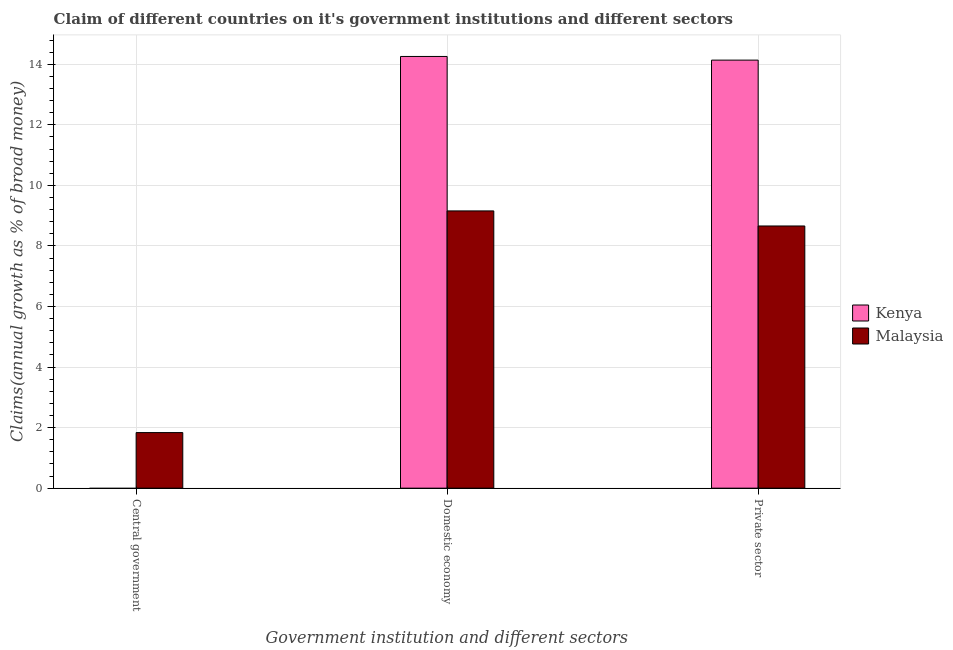Are the number of bars per tick equal to the number of legend labels?
Your response must be concise. No. How many bars are there on the 1st tick from the left?
Offer a very short reply. 1. What is the label of the 1st group of bars from the left?
Offer a terse response. Central government. What is the percentage of claim on the domestic economy in Kenya?
Make the answer very short. 14.26. Across all countries, what is the maximum percentage of claim on the domestic economy?
Ensure brevity in your answer.  14.26. In which country was the percentage of claim on the domestic economy maximum?
Your answer should be compact. Kenya. What is the total percentage of claim on the central government in the graph?
Your answer should be compact. 1.84. What is the difference between the percentage of claim on the private sector in Kenya and that in Malaysia?
Your answer should be very brief. 5.48. What is the difference between the percentage of claim on the central government in Kenya and the percentage of claim on the private sector in Malaysia?
Give a very brief answer. -8.66. What is the average percentage of claim on the central government per country?
Give a very brief answer. 0.92. What is the difference between the percentage of claim on the central government and percentage of claim on the private sector in Malaysia?
Offer a very short reply. -6.82. In how many countries, is the percentage of claim on the central government greater than 9.6 %?
Give a very brief answer. 0. What is the ratio of the percentage of claim on the domestic economy in Kenya to that in Malaysia?
Provide a short and direct response. 1.56. Is the percentage of claim on the domestic economy in Kenya less than that in Malaysia?
Make the answer very short. No. Is the difference between the percentage of claim on the private sector in Kenya and Malaysia greater than the difference between the percentage of claim on the domestic economy in Kenya and Malaysia?
Offer a terse response. Yes. What is the difference between the highest and the second highest percentage of claim on the private sector?
Provide a succinct answer. 5.48. What is the difference between the highest and the lowest percentage of claim on the central government?
Keep it short and to the point. 1.84. In how many countries, is the percentage of claim on the domestic economy greater than the average percentage of claim on the domestic economy taken over all countries?
Your answer should be compact. 1. How many countries are there in the graph?
Your answer should be very brief. 2. What is the difference between two consecutive major ticks on the Y-axis?
Provide a succinct answer. 2. Are the values on the major ticks of Y-axis written in scientific E-notation?
Provide a short and direct response. No. Does the graph contain any zero values?
Make the answer very short. Yes. How are the legend labels stacked?
Offer a terse response. Vertical. What is the title of the graph?
Make the answer very short. Claim of different countries on it's government institutions and different sectors. Does "Angola" appear as one of the legend labels in the graph?
Offer a very short reply. No. What is the label or title of the X-axis?
Give a very brief answer. Government institution and different sectors. What is the label or title of the Y-axis?
Offer a terse response. Claims(annual growth as % of broad money). What is the Claims(annual growth as % of broad money) in Malaysia in Central government?
Give a very brief answer. 1.84. What is the Claims(annual growth as % of broad money) in Kenya in Domestic economy?
Your answer should be very brief. 14.26. What is the Claims(annual growth as % of broad money) of Malaysia in Domestic economy?
Provide a succinct answer. 9.16. What is the Claims(annual growth as % of broad money) in Kenya in Private sector?
Provide a short and direct response. 14.14. What is the Claims(annual growth as % of broad money) in Malaysia in Private sector?
Your answer should be compact. 8.66. Across all Government institution and different sectors, what is the maximum Claims(annual growth as % of broad money) in Kenya?
Ensure brevity in your answer.  14.26. Across all Government institution and different sectors, what is the maximum Claims(annual growth as % of broad money) in Malaysia?
Provide a succinct answer. 9.16. Across all Government institution and different sectors, what is the minimum Claims(annual growth as % of broad money) in Kenya?
Offer a very short reply. 0. Across all Government institution and different sectors, what is the minimum Claims(annual growth as % of broad money) in Malaysia?
Your answer should be compact. 1.84. What is the total Claims(annual growth as % of broad money) of Kenya in the graph?
Provide a succinct answer. 28.39. What is the total Claims(annual growth as % of broad money) of Malaysia in the graph?
Provide a short and direct response. 19.65. What is the difference between the Claims(annual growth as % of broad money) in Malaysia in Central government and that in Domestic economy?
Ensure brevity in your answer.  -7.32. What is the difference between the Claims(annual growth as % of broad money) of Malaysia in Central government and that in Private sector?
Your answer should be compact. -6.82. What is the difference between the Claims(annual growth as % of broad money) in Kenya in Domestic economy and that in Private sector?
Offer a terse response. 0.12. What is the difference between the Claims(annual growth as % of broad money) in Malaysia in Domestic economy and that in Private sector?
Give a very brief answer. 0.5. What is the difference between the Claims(annual growth as % of broad money) of Kenya in Domestic economy and the Claims(annual growth as % of broad money) of Malaysia in Private sector?
Your response must be concise. 5.6. What is the average Claims(annual growth as % of broad money) of Kenya per Government institution and different sectors?
Provide a succinct answer. 9.46. What is the average Claims(annual growth as % of broad money) in Malaysia per Government institution and different sectors?
Your answer should be compact. 6.55. What is the difference between the Claims(annual growth as % of broad money) of Kenya and Claims(annual growth as % of broad money) of Malaysia in Domestic economy?
Offer a very short reply. 5.1. What is the difference between the Claims(annual growth as % of broad money) in Kenya and Claims(annual growth as % of broad money) in Malaysia in Private sector?
Ensure brevity in your answer.  5.48. What is the ratio of the Claims(annual growth as % of broad money) of Malaysia in Central government to that in Domestic economy?
Keep it short and to the point. 0.2. What is the ratio of the Claims(annual growth as % of broad money) of Malaysia in Central government to that in Private sector?
Your answer should be compact. 0.21. What is the ratio of the Claims(annual growth as % of broad money) in Kenya in Domestic economy to that in Private sector?
Offer a very short reply. 1.01. What is the ratio of the Claims(annual growth as % of broad money) of Malaysia in Domestic economy to that in Private sector?
Provide a succinct answer. 1.06. What is the difference between the highest and the second highest Claims(annual growth as % of broad money) in Malaysia?
Ensure brevity in your answer.  0.5. What is the difference between the highest and the lowest Claims(annual growth as % of broad money) of Kenya?
Your response must be concise. 14.26. What is the difference between the highest and the lowest Claims(annual growth as % of broad money) of Malaysia?
Offer a very short reply. 7.32. 